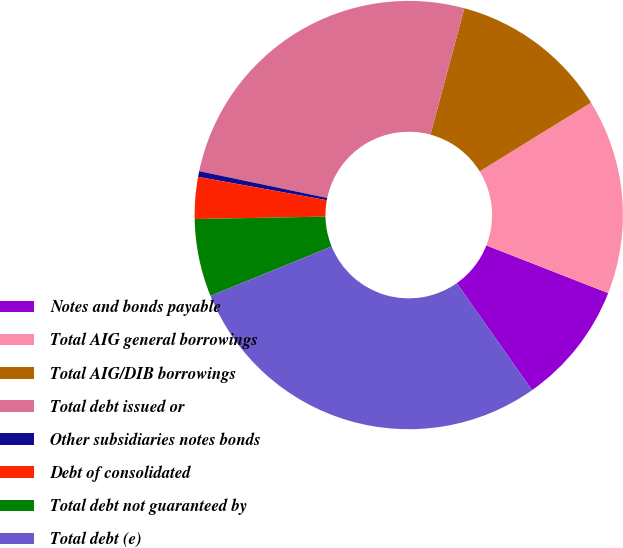Convert chart. <chart><loc_0><loc_0><loc_500><loc_500><pie_chart><fcel>Notes and bonds payable<fcel>Total AIG general borrowings<fcel>Total AIG/DIB borrowings<fcel>Total debt issued or<fcel>Other subsidiaries notes bonds<fcel>Debt of consolidated<fcel>Total debt not guaranteed by<fcel>Total debt (e)<nl><fcel>9.3%<fcel>14.73%<fcel>12.02%<fcel>25.89%<fcel>0.43%<fcel>3.15%<fcel>5.86%<fcel>28.6%<nl></chart> 